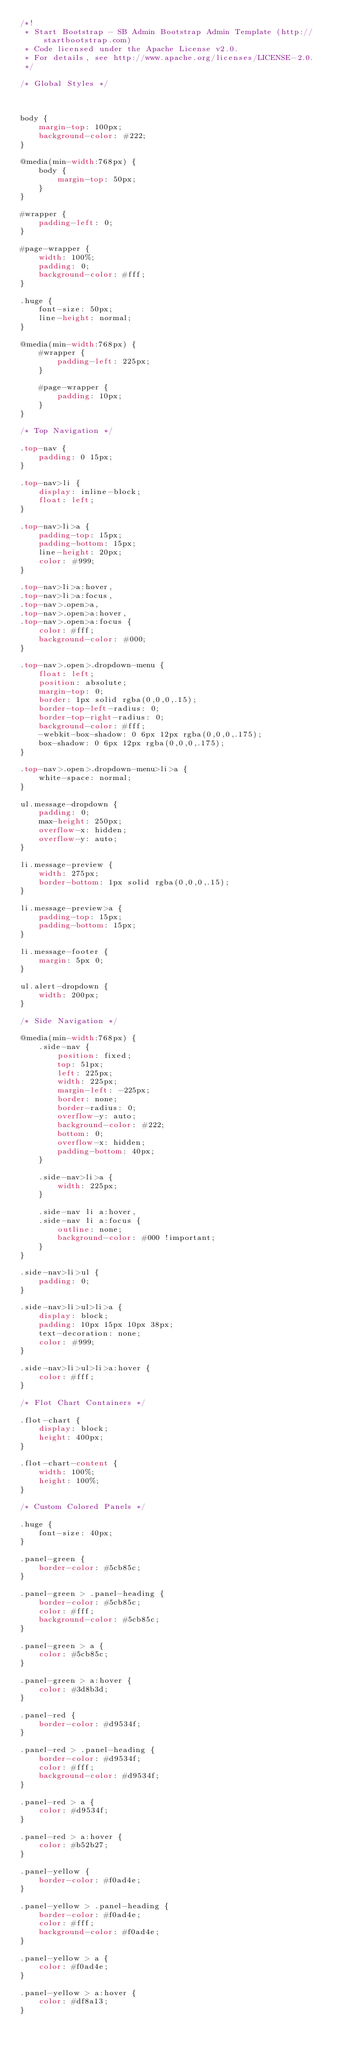Convert code to text. <code><loc_0><loc_0><loc_500><loc_500><_CSS_>/*!
 * Start Bootstrap - SB Admin Bootstrap Admin Template (http://startbootstrap.com)
 * Code licensed under the Apache License v2.0.
 * For details, see http://www.apache.org/licenses/LICENSE-2.0.
 */

/* Global Styles */



body {
    margin-top: 100px;
    background-color: #222;
}

@media(min-width:768px) {
    body {
        margin-top: 50px;
    }
}

#wrapper {
    padding-left: 0;
}

#page-wrapper {
    width: 100%;
    padding: 0;
    background-color: #fff;
}

.huge {
    font-size: 50px;
    line-height: normal;
}

@media(min-width:768px) {
    #wrapper {
        padding-left: 225px;
    }

    #page-wrapper {
        padding: 10px;
    }
}

/* Top Navigation */

.top-nav {
    padding: 0 15px;
}

.top-nav>li {
    display: inline-block;
    float: left;
}

.top-nav>li>a {
    padding-top: 15px;
    padding-bottom: 15px;
    line-height: 20px;
    color: #999;
}

.top-nav>li>a:hover,
.top-nav>li>a:focus,
.top-nav>.open>a,
.top-nav>.open>a:hover,
.top-nav>.open>a:focus {
    color: #fff;
    background-color: #000;
}

.top-nav>.open>.dropdown-menu {
    float: left;
    position: absolute;
    margin-top: 0;
    border: 1px solid rgba(0,0,0,.15);
    border-top-left-radius: 0;
    border-top-right-radius: 0;
    background-color: #fff;
    -webkit-box-shadow: 0 6px 12px rgba(0,0,0,.175);
    box-shadow: 0 6px 12px rgba(0,0,0,.175);
}

.top-nav>.open>.dropdown-menu>li>a {
    white-space: normal;
}

ul.message-dropdown {
    padding: 0;
    max-height: 250px;
    overflow-x: hidden;
    overflow-y: auto;
}

li.message-preview {
    width: 275px;
    border-bottom: 1px solid rgba(0,0,0,.15);
}

li.message-preview>a {
    padding-top: 15px;
    padding-bottom: 15px;
}

li.message-footer {
    margin: 5px 0;
}

ul.alert-dropdown {
    width: 200px;
}

/* Side Navigation */

@media(min-width:768px) {
    .side-nav {
        position: fixed;
        top: 51px;
        left: 225px;
        width: 225px;
        margin-left: -225px;
        border: none;
        border-radius: 0;
        overflow-y: auto;
        background-color: #222;
        bottom: 0;
        overflow-x: hidden;
        padding-bottom: 40px;
    }

    .side-nav>li>a {
        width: 225px;
    }

    .side-nav li a:hover,
    .side-nav li a:focus {
        outline: none;
        background-color: #000 !important;
    }
}

.side-nav>li>ul {
    padding: 0;
}

.side-nav>li>ul>li>a {
    display: block;
    padding: 10px 15px 10px 38px;
    text-decoration: none;
    color: #999;
}

.side-nav>li>ul>li>a:hover {
    color: #fff;
}

/* Flot Chart Containers */

.flot-chart {
    display: block;
    height: 400px;
}

.flot-chart-content {
    width: 100%;
    height: 100%;
}

/* Custom Colored Panels */

.huge {
    font-size: 40px;
}

.panel-green {
    border-color: #5cb85c;
}

.panel-green > .panel-heading {
    border-color: #5cb85c;
    color: #fff;
    background-color: #5cb85c;
}

.panel-green > a {
    color: #5cb85c;
}

.panel-green > a:hover {
    color: #3d8b3d;
}

.panel-red {
    border-color: #d9534f;
}

.panel-red > .panel-heading {
    border-color: #d9534f;
    color: #fff;
    background-color: #d9534f;
}

.panel-red > a {
    color: #d9534f;
}

.panel-red > a:hover {
    color: #b52b27;
}

.panel-yellow {
    border-color: #f0ad4e;
}

.panel-yellow > .panel-heading {
    border-color: #f0ad4e;
    color: #fff;
    background-color: #f0ad4e;
}

.panel-yellow > a {
    color: #f0ad4e;
}

.panel-yellow > a:hover {
    color: #df8a13;
}
</code> 